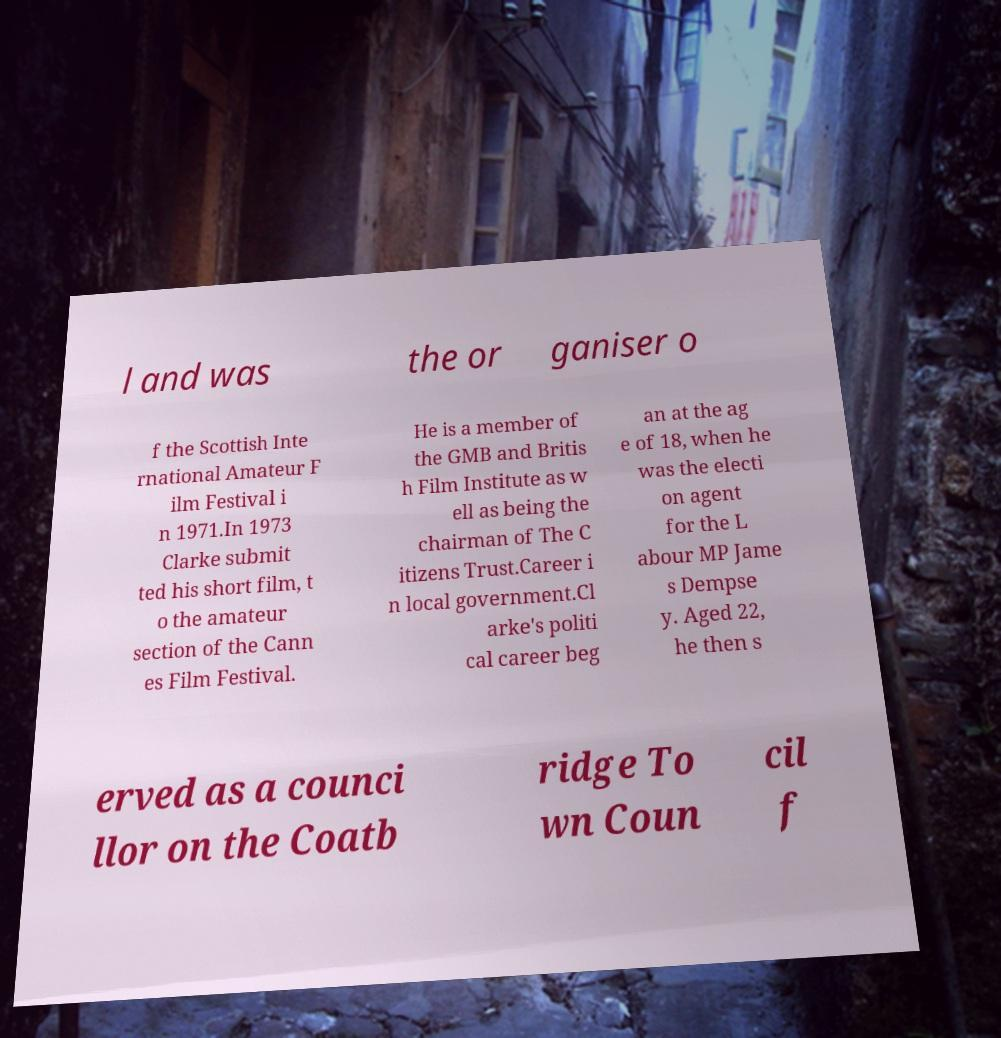There's text embedded in this image that I need extracted. Can you transcribe it verbatim? l and was the or ganiser o f the Scottish Inte rnational Amateur F ilm Festival i n 1971.In 1973 Clarke submit ted his short film, t o the amateur section of the Cann es Film Festival. He is a member of the GMB and Britis h Film Institute as w ell as being the chairman of The C itizens Trust.Career i n local government.Cl arke's politi cal career beg an at the ag e of 18, when he was the electi on agent for the L abour MP Jame s Dempse y. Aged 22, he then s erved as a counci llor on the Coatb ridge To wn Coun cil f 